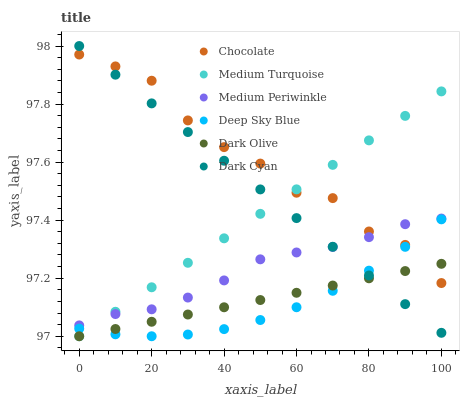Does Deep Sky Blue have the minimum area under the curve?
Answer yes or no. Yes. Does Chocolate have the maximum area under the curve?
Answer yes or no. Yes. Does Dark Olive have the minimum area under the curve?
Answer yes or no. No. Does Dark Olive have the maximum area under the curve?
Answer yes or no. No. Is Medium Turquoise the smoothest?
Answer yes or no. Yes. Is Chocolate the roughest?
Answer yes or no. Yes. Is Dark Olive the smoothest?
Answer yes or no. No. Is Dark Olive the roughest?
Answer yes or no. No. Does Medium Turquoise have the lowest value?
Answer yes or no. Yes. Does Medium Periwinkle have the lowest value?
Answer yes or no. No. Does Dark Cyan have the highest value?
Answer yes or no. Yes. Does Medium Periwinkle have the highest value?
Answer yes or no. No. Is Dark Olive less than Medium Periwinkle?
Answer yes or no. Yes. Is Medium Periwinkle greater than Deep Sky Blue?
Answer yes or no. Yes. Does Chocolate intersect Dark Cyan?
Answer yes or no. Yes. Is Chocolate less than Dark Cyan?
Answer yes or no. No. Is Chocolate greater than Dark Cyan?
Answer yes or no. No. Does Dark Olive intersect Medium Periwinkle?
Answer yes or no. No. 